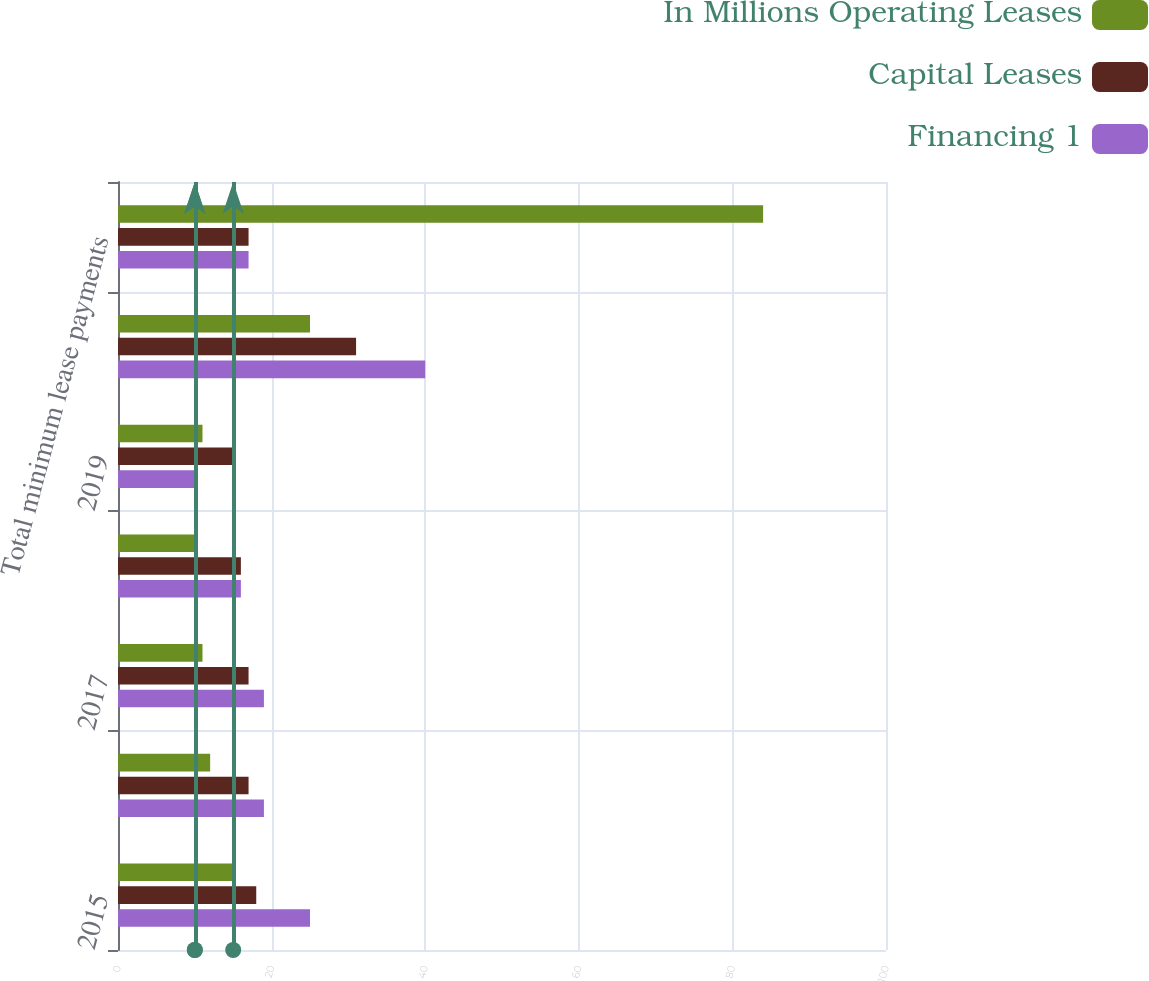Convert chart. <chart><loc_0><loc_0><loc_500><loc_500><stacked_bar_chart><ecel><fcel>2015<fcel>2016<fcel>2017<fcel>2018<fcel>2019<fcel>2020 and thereafter<fcel>Total minimum lease payments<nl><fcel>In Millions Operating Leases<fcel>15<fcel>12<fcel>11<fcel>10<fcel>11<fcel>25<fcel>84<nl><fcel>Capital Leases<fcel>18<fcel>17<fcel>17<fcel>16<fcel>15<fcel>31<fcel>17<nl><fcel>Financing 1<fcel>25<fcel>19<fcel>19<fcel>16<fcel>10<fcel>40<fcel>17<nl></chart> 